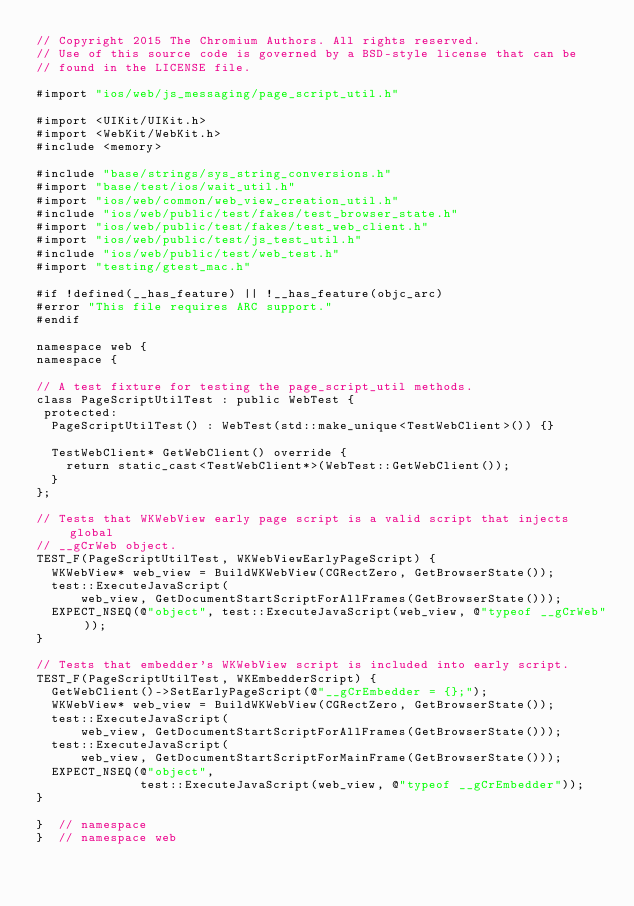<code> <loc_0><loc_0><loc_500><loc_500><_ObjectiveC_>// Copyright 2015 The Chromium Authors. All rights reserved.
// Use of this source code is governed by a BSD-style license that can be
// found in the LICENSE file.

#import "ios/web/js_messaging/page_script_util.h"

#import <UIKit/UIKit.h>
#import <WebKit/WebKit.h>
#include <memory>

#include "base/strings/sys_string_conversions.h"
#import "base/test/ios/wait_util.h"
#import "ios/web/common/web_view_creation_util.h"
#include "ios/web/public/test/fakes/test_browser_state.h"
#import "ios/web/public/test/fakes/test_web_client.h"
#import "ios/web/public/test/js_test_util.h"
#include "ios/web/public/test/web_test.h"
#import "testing/gtest_mac.h"

#if !defined(__has_feature) || !__has_feature(objc_arc)
#error "This file requires ARC support."
#endif

namespace web {
namespace {

// A test fixture for testing the page_script_util methods.
class PageScriptUtilTest : public WebTest {
 protected:
  PageScriptUtilTest() : WebTest(std::make_unique<TestWebClient>()) {}

  TestWebClient* GetWebClient() override {
    return static_cast<TestWebClient*>(WebTest::GetWebClient());
  }
};

// Tests that WKWebView early page script is a valid script that injects global
// __gCrWeb object.
TEST_F(PageScriptUtilTest, WKWebViewEarlyPageScript) {
  WKWebView* web_view = BuildWKWebView(CGRectZero, GetBrowserState());
  test::ExecuteJavaScript(
      web_view, GetDocumentStartScriptForAllFrames(GetBrowserState()));
  EXPECT_NSEQ(@"object", test::ExecuteJavaScript(web_view, @"typeof __gCrWeb"));
}

// Tests that embedder's WKWebView script is included into early script.
TEST_F(PageScriptUtilTest, WKEmbedderScript) {
  GetWebClient()->SetEarlyPageScript(@"__gCrEmbedder = {};");
  WKWebView* web_view = BuildWKWebView(CGRectZero, GetBrowserState());
  test::ExecuteJavaScript(
      web_view, GetDocumentStartScriptForAllFrames(GetBrowserState()));
  test::ExecuteJavaScript(
      web_view, GetDocumentStartScriptForMainFrame(GetBrowserState()));
  EXPECT_NSEQ(@"object",
              test::ExecuteJavaScript(web_view, @"typeof __gCrEmbedder"));
}

}  // namespace
}  // namespace web
</code> 